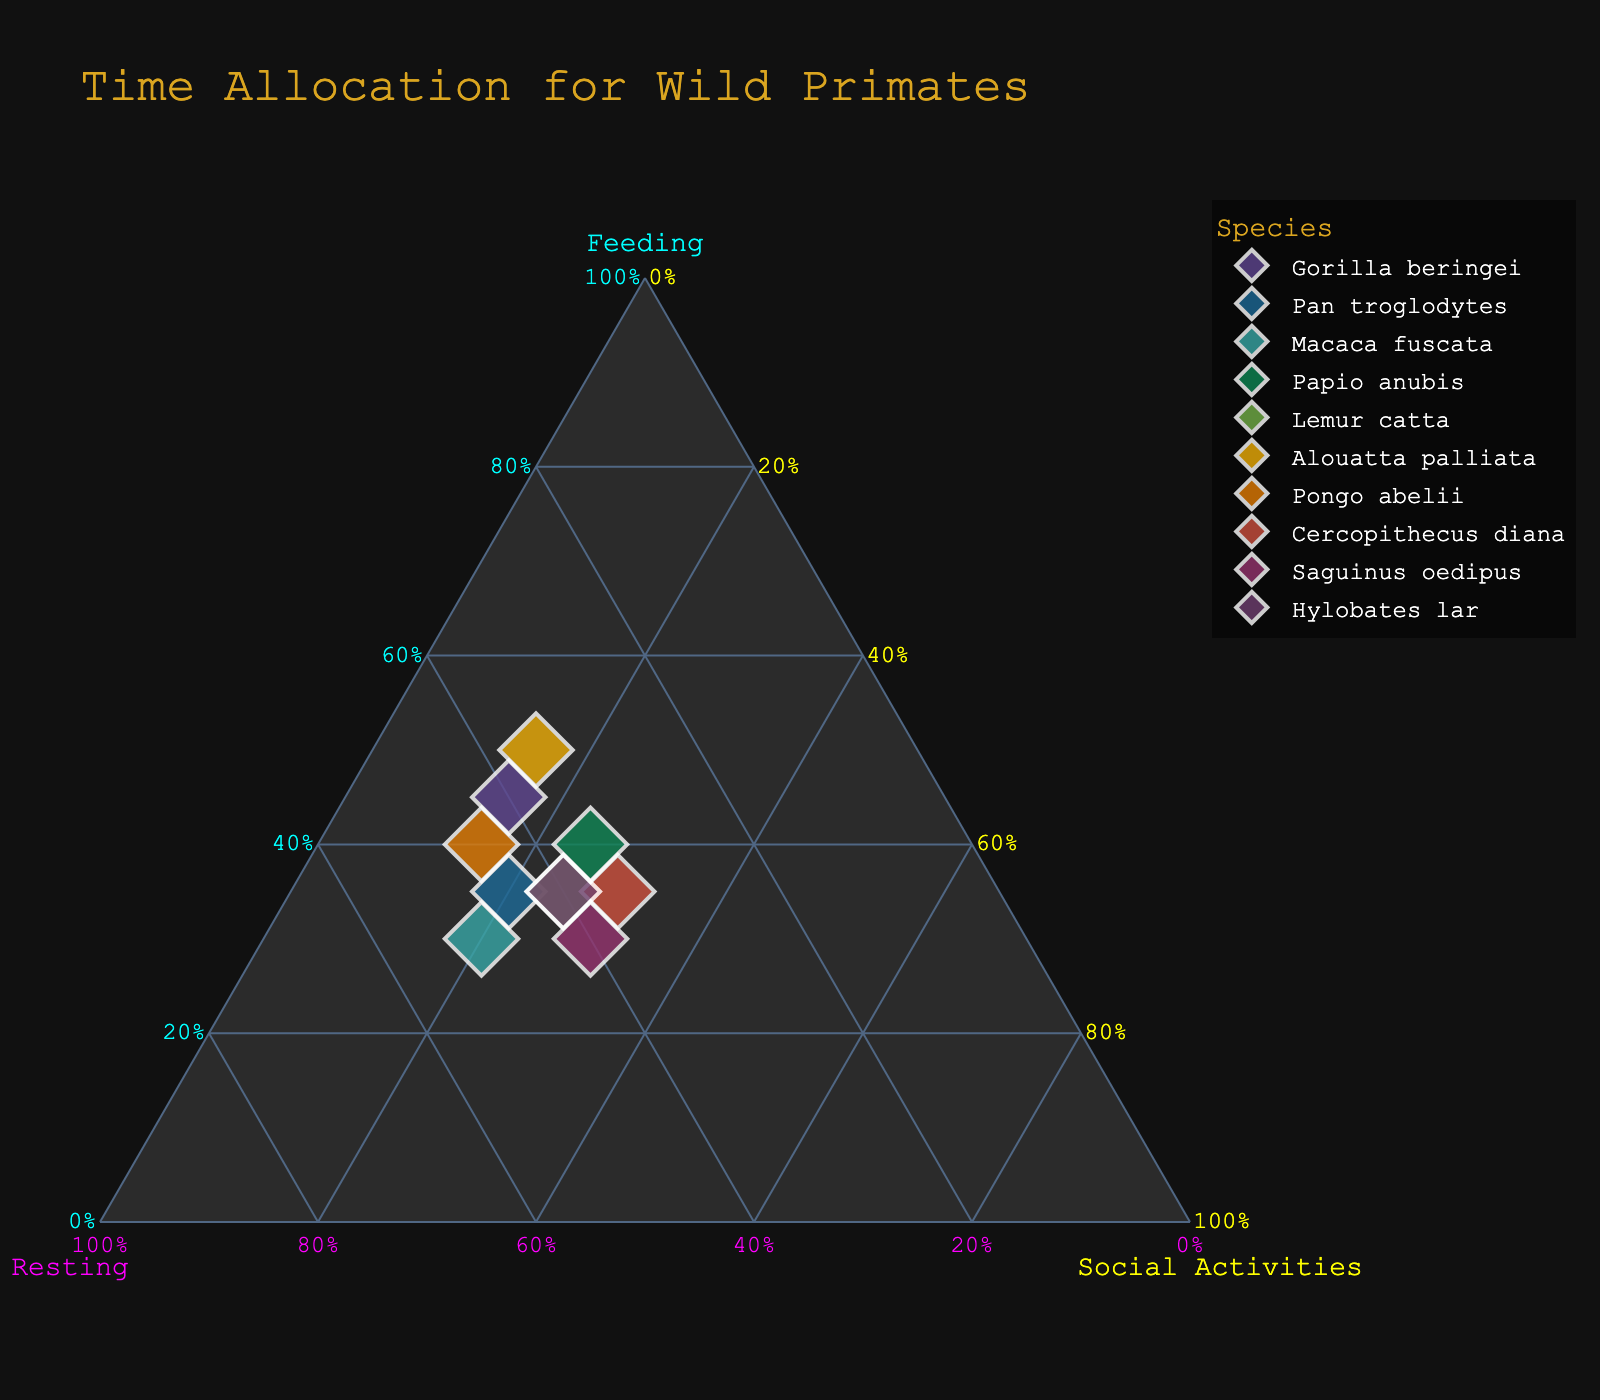what is the title of the figure? The title of the figure is typically at the top and in a larger font size. It is used to describe the overall theme or subject of the plot.
Answer: Time Allocation for Wild Primates how many primate species are included in the plot? Count the number of data points or labels on the plot; each represents a different primate species.
Answer: 10 which species spends the most time feeding? Identify the species with the highest percentage on the "Feeding" axis of the ternary plot.
Answer: Alouatta palliata which species dedicates equal proportions of time to resting and social activities? Look for species where the values of "Resting" and "Social Activities" are equal.
Answer: Cercopithecus diana what is the average time spent on social activities by all species? Sum the percentages allocated to social activities for all species and divide by the number of species. (15 + 20 + 20 + 25 + 25 + 15 + 15 + 30 + 30 + 25) / 10 = 22
Answer: 22 which two species have the same time allocation for feeding? Identify species where the percentage of time allocated to feeding is the same.
Answer: Pan troglodytes and Lemur catta which axis has the highest overall allocation when summed across all species? Sum the percentages of each time allocation (Feeding, Resting, Social Activities) for all species and compare the totals. (390, 415, 220)
Answer: Resting are there any species which spend less than 20% of their time on social activities? Look for species where the social activities percentage is less than 20%.
Answer: Gorilla beringei, Alouatta palliata, Pongo abelii which species has the largest slice allocated to resting? Identify the species with the highest percentage on the "Resting" axis.
Answer: Macaca fuscata which activity does Hylobates lar spend 35% of its time on? Look for the allocation values specific to Hylobates lar and identify which activity corresponds to 35%.
Answer: Feeding 